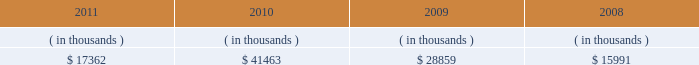Entergy arkansas , inc .
And subsidiaries management 2019s financial discussion and analysis entergy arkansas 2019s receivables from the money pool were as follows as of december 31 for each of the following years: .
In april 2011 , entergy arkansas entered into a new $ 78 million credit facility that expires in april 2012 .
There were no outstanding borrowings under the entergy arkansas credit facility as of december 31 , 2011 .
Entergy arkansas has obtained short-term borrowing authorization from the ferc under which it may borrow through october 2013 , up to the aggregate amount , at any one time outstanding , of $ 250 million .
See note 4 to the financial statements for further discussion of entergy arkansas 2019s short-term borrowing limits .
Entergy arkansas has also obtained an order from the apsc authorizing long-term securities issuances through december state and local rate regulation and fuel-cost recovery retail rates 2009 base rate filing in september 2009 , entergy arkansas filed with the apsc for a general change in rates , charges , and tariffs .
In june 2010 the apsc approved a settlement and subsequent compliance tariffs that provide for a $ 63.7 million rate increase , effective for bills rendered for the first billing cycle of july 2010 .
The settlement provides for a 10.2% ( 10.2 % ) return on common equity .
Production cost allocation rider the apsc approved a production cost allocation rider for recovery from customers of the retail portion of the costs allocated to entergy arkansas as a result of the system agreement proceedings .
These costs cause an increase in entergy arkansas 2019s deferred fuel cost balance , because entergy arkansas pays the costs over seven months but collects them from customers over twelve months .
See note 2 to the financial statements and entergy corporation and subsidiaries 201cmanagement 2019s financial discussion and analysis - system agreement 201d for discussions of the system agreement proceedings .
Energy cost recovery rider entergy arkansas 2019s retail rates include an energy cost recovery rider to recover fuel and purchased energy costs in monthly bills .
The rider utilizes prior calendar year energy costs and projected energy sales for the twelve- month period commencing on april 1 of each year to develop an energy cost rate , which is redetermined annually and includes a true-up adjustment reflecting the over-recovery or under-recovery , including carrying charges , of the energy cost for the prior calendar year .
The energy cost recovery rider tariff also allows an interim rate request depending upon the level of over- or under-recovery of fuel and purchased energy costs .
In early october 2005 , the apsc initiated an investigation into entergy arkansas's interim energy cost recovery rate .
The investigation focused on entergy arkansas's 1 ) gas contracting , portfolio , and hedging practices ; 2 ) wholesale purchases during the period ; 3 ) management of the coal inventory at its coal generation plants ; and 4 ) response to the contractual failure of the railroads to provide coal deliveries .
In march 2006 , the apsc extended its investigation to cover the costs included in entergy arkansas's march 2006 annual energy cost rate filing , and a hearing was held in the apsc energy cost recovery investigation in october 2006. .
What was the average receivables for entergy arkansas from 2008 to 2011? 
Computations: ((15991 + (28859 + (17362 + 41463))) + 4)
Answer: 103679.0. 